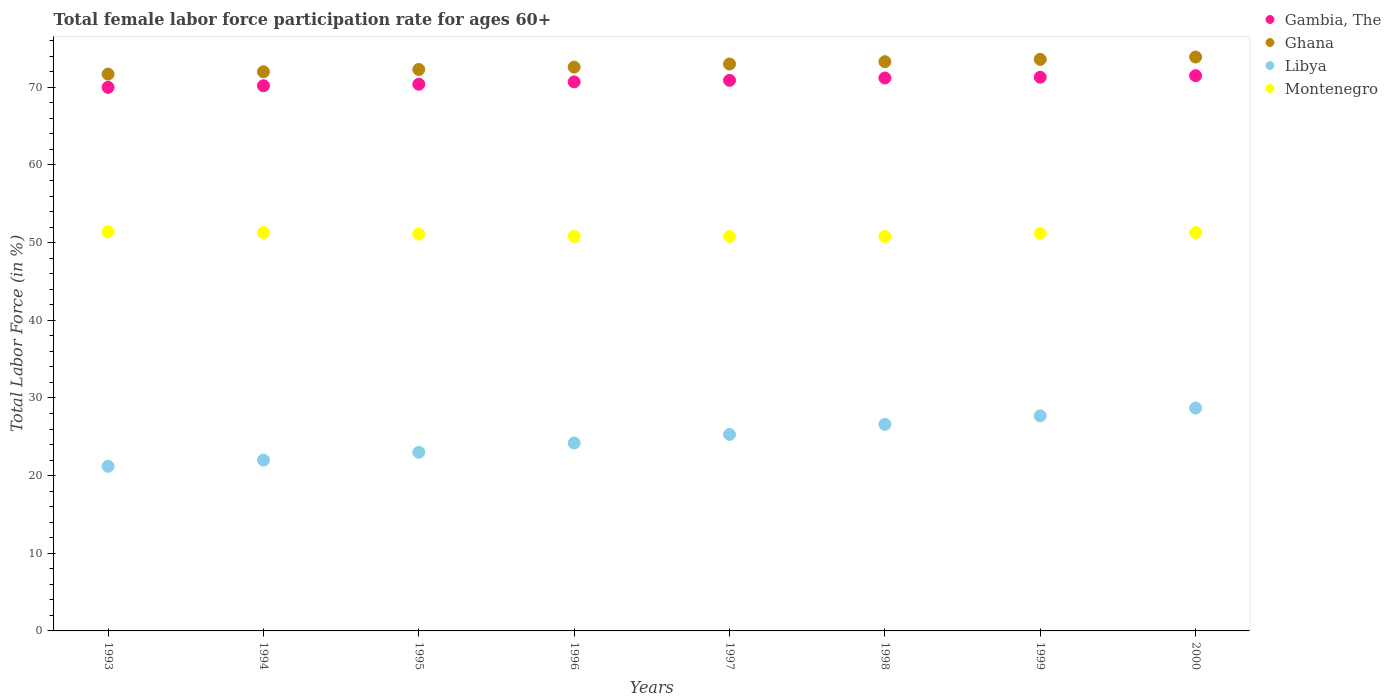What is the female labor force participation rate in Gambia, The in 1997?
Give a very brief answer. 70.9. Across all years, what is the maximum female labor force participation rate in Gambia, The?
Your answer should be compact. 71.5. Across all years, what is the minimum female labor force participation rate in Ghana?
Ensure brevity in your answer.  71.7. In which year was the female labor force participation rate in Libya maximum?
Provide a short and direct response. 2000. What is the total female labor force participation rate in Ghana in the graph?
Your response must be concise. 582.4. What is the difference between the female labor force participation rate in Ghana in 1995 and that in 1999?
Offer a terse response. -1.3. What is the difference between the female labor force participation rate in Ghana in 1994 and the female labor force participation rate in Montenegro in 1996?
Your response must be concise. 21.2. What is the average female labor force participation rate in Gambia, The per year?
Offer a terse response. 70.77. In the year 1993, what is the difference between the female labor force participation rate in Ghana and female labor force participation rate in Montenegro?
Give a very brief answer. 20.3. What is the ratio of the female labor force participation rate in Montenegro in 1995 to that in 2000?
Your answer should be compact. 1. Is the female labor force participation rate in Libya in 1995 less than that in 2000?
Offer a very short reply. Yes. Is the difference between the female labor force participation rate in Ghana in 1998 and 2000 greater than the difference between the female labor force participation rate in Montenegro in 1998 and 2000?
Offer a terse response. No. What is the difference between the highest and the second highest female labor force participation rate in Ghana?
Provide a short and direct response. 0.3. What is the difference between the highest and the lowest female labor force participation rate in Ghana?
Your answer should be very brief. 2.2. Is the sum of the female labor force participation rate in Montenegro in 1998 and 1999 greater than the maximum female labor force participation rate in Libya across all years?
Your answer should be compact. Yes. Is it the case that in every year, the sum of the female labor force participation rate in Libya and female labor force participation rate in Ghana  is greater than the female labor force participation rate in Gambia, The?
Provide a short and direct response. Yes. How many years are there in the graph?
Your answer should be compact. 8. Are the values on the major ticks of Y-axis written in scientific E-notation?
Your answer should be very brief. No. Where does the legend appear in the graph?
Your answer should be very brief. Top right. How many legend labels are there?
Provide a short and direct response. 4. How are the legend labels stacked?
Your response must be concise. Vertical. What is the title of the graph?
Provide a succinct answer. Total female labor force participation rate for ages 60+. Does "Iceland" appear as one of the legend labels in the graph?
Offer a very short reply. No. What is the label or title of the X-axis?
Ensure brevity in your answer.  Years. What is the label or title of the Y-axis?
Provide a succinct answer. Total Labor Force (in %). What is the Total Labor Force (in %) of Gambia, The in 1993?
Your response must be concise. 70. What is the Total Labor Force (in %) of Ghana in 1993?
Ensure brevity in your answer.  71.7. What is the Total Labor Force (in %) of Libya in 1993?
Keep it short and to the point. 21.2. What is the Total Labor Force (in %) in Montenegro in 1993?
Give a very brief answer. 51.4. What is the Total Labor Force (in %) in Gambia, The in 1994?
Your answer should be compact. 70.2. What is the Total Labor Force (in %) of Ghana in 1994?
Give a very brief answer. 72. What is the Total Labor Force (in %) in Montenegro in 1994?
Your answer should be compact. 51.3. What is the Total Labor Force (in %) of Gambia, The in 1995?
Keep it short and to the point. 70.4. What is the Total Labor Force (in %) in Ghana in 1995?
Your response must be concise. 72.3. What is the Total Labor Force (in %) of Libya in 1995?
Make the answer very short. 23. What is the Total Labor Force (in %) in Montenegro in 1995?
Your response must be concise. 51.1. What is the Total Labor Force (in %) in Gambia, The in 1996?
Offer a very short reply. 70.7. What is the Total Labor Force (in %) of Ghana in 1996?
Offer a very short reply. 72.6. What is the Total Labor Force (in %) of Libya in 1996?
Provide a short and direct response. 24.2. What is the Total Labor Force (in %) of Montenegro in 1996?
Offer a terse response. 50.8. What is the Total Labor Force (in %) of Gambia, The in 1997?
Offer a very short reply. 70.9. What is the Total Labor Force (in %) of Libya in 1997?
Offer a terse response. 25.3. What is the Total Labor Force (in %) of Montenegro in 1997?
Offer a very short reply. 50.8. What is the Total Labor Force (in %) of Gambia, The in 1998?
Your answer should be compact. 71.2. What is the Total Labor Force (in %) in Ghana in 1998?
Provide a succinct answer. 73.3. What is the Total Labor Force (in %) in Libya in 1998?
Give a very brief answer. 26.6. What is the Total Labor Force (in %) in Montenegro in 1998?
Offer a terse response. 50.8. What is the Total Labor Force (in %) of Gambia, The in 1999?
Provide a succinct answer. 71.3. What is the Total Labor Force (in %) of Ghana in 1999?
Make the answer very short. 73.6. What is the Total Labor Force (in %) of Libya in 1999?
Your answer should be very brief. 27.7. What is the Total Labor Force (in %) in Montenegro in 1999?
Give a very brief answer. 51.2. What is the Total Labor Force (in %) in Gambia, The in 2000?
Your answer should be very brief. 71.5. What is the Total Labor Force (in %) of Ghana in 2000?
Your response must be concise. 73.9. What is the Total Labor Force (in %) of Libya in 2000?
Make the answer very short. 28.7. What is the Total Labor Force (in %) of Montenegro in 2000?
Your answer should be compact. 51.3. Across all years, what is the maximum Total Labor Force (in %) in Gambia, The?
Keep it short and to the point. 71.5. Across all years, what is the maximum Total Labor Force (in %) in Ghana?
Offer a terse response. 73.9. Across all years, what is the maximum Total Labor Force (in %) in Libya?
Your answer should be compact. 28.7. Across all years, what is the maximum Total Labor Force (in %) in Montenegro?
Ensure brevity in your answer.  51.4. Across all years, what is the minimum Total Labor Force (in %) in Gambia, The?
Provide a succinct answer. 70. Across all years, what is the minimum Total Labor Force (in %) in Ghana?
Provide a short and direct response. 71.7. Across all years, what is the minimum Total Labor Force (in %) of Libya?
Offer a very short reply. 21.2. Across all years, what is the minimum Total Labor Force (in %) in Montenegro?
Provide a succinct answer. 50.8. What is the total Total Labor Force (in %) in Gambia, The in the graph?
Your answer should be compact. 566.2. What is the total Total Labor Force (in %) in Ghana in the graph?
Ensure brevity in your answer.  582.4. What is the total Total Labor Force (in %) in Libya in the graph?
Your answer should be compact. 198.7. What is the total Total Labor Force (in %) of Montenegro in the graph?
Make the answer very short. 408.7. What is the difference between the Total Labor Force (in %) of Gambia, The in 1993 and that in 1994?
Give a very brief answer. -0.2. What is the difference between the Total Labor Force (in %) of Ghana in 1993 and that in 1994?
Your answer should be very brief. -0.3. What is the difference between the Total Labor Force (in %) in Gambia, The in 1993 and that in 1997?
Your response must be concise. -0.9. What is the difference between the Total Labor Force (in %) in Ghana in 1993 and that in 1997?
Your answer should be very brief. -1.3. What is the difference between the Total Labor Force (in %) in Libya in 1993 and that in 1997?
Offer a very short reply. -4.1. What is the difference between the Total Labor Force (in %) of Gambia, The in 1993 and that in 1998?
Make the answer very short. -1.2. What is the difference between the Total Labor Force (in %) of Ghana in 1993 and that in 1998?
Your answer should be very brief. -1.6. What is the difference between the Total Labor Force (in %) in Montenegro in 1993 and that in 1998?
Keep it short and to the point. 0.6. What is the difference between the Total Labor Force (in %) of Gambia, The in 1993 and that in 1999?
Your answer should be very brief. -1.3. What is the difference between the Total Labor Force (in %) in Ghana in 1993 and that in 2000?
Your answer should be compact. -2.2. What is the difference between the Total Labor Force (in %) of Libya in 1994 and that in 1995?
Offer a terse response. -1. What is the difference between the Total Labor Force (in %) of Gambia, The in 1994 and that in 1996?
Keep it short and to the point. -0.5. What is the difference between the Total Labor Force (in %) of Ghana in 1994 and that in 1997?
Provide a short and direct response. -1. What is the difference between the Total Labor Force (in %) of Gambia, The in 1994 and that in 1998?
Provide a short and direct response. -1. What is the difference between the Total Labor Force (in %) in Ghana in 1994 and that in 1998?
Your response must be concise. -1.3. What is the difference between the Total Labor Force (in %) of Montenegro in 1994 and that in 1998?
Keep it short and to the point. 0.5. What is the difference between the Total Labor Force (in %) of Gambia, The in 1994 and that in 1999?
Give a very brief answer. -1.1. What is the difference between the Total Labor Force (in %) in Ghana in 1994 and that in 1999?
Your response must be concise. -1.6. What is the difference between the Total Labor Force (in %) in Libya in 1994 and that in 1999?
Offer a terse response. -5.7. What is the difference between the Total Labor Force (in %) in Montenegro in 1994 and that in 1999?
Ensure brevity in your answer.  0.1. What is the difference between the Total Labor Force (in %) in Ghana in 1994 and that in 2000?
Offer a terse response. -1.9. What is the difference between the Total Labor Force (in %) in Libya in 1994 and that in 2000?
Keep it short and to the point. -6.7. What is the difference between the Total Labor Force (in %) in Montenegro in 1994 and that in 2000?
Your response must be concise. 0. What is the difference between the Total Labor Force (in %) of Libya in 1995 and that in 1996?
Offer a very short reply. -1.2. What is the difference between the Total Labor Force (in %) in Ghana in 1995 and that in 1997?
Provide a succinct answer. -0.7. What is the difference between the Total Labor Force (in %) of Libya in 1995 and that in 1997?
Provide a short and direct response. -2.3. What is the difference between the Total Labor Force (in %) in Montenegro in 1995 and that in 1997?
Your answer should be very brief. 0.3. What is the difference between the Total Labor Force (in %) in Gambia, The in 1995 and that in 1998?
Ensure brevity in your answer.  -0.8. What is the difference between the Total Labor Force (in %) of Ghana in 1995 and that in 1998?
Offer a very short reply. -1. What is the difference between the Total Labor Force (in %) of Libya in 1995 and that in 1998?
Offer a very short reply. -3.6. What is the difference between the Total Labor Force (in %) in Montenegro in 1995 and that in 1998?
Make the answer very short. 0.3. What is the difference between the Total Labor Force (in %) in Gambia, The in 1995 and that in 1999?
Your response must be concise. -0.9. What is the difference between the Total Labor Force (in %) of Ghana in 1995 and that in 1999?
Offer a very short reply. -1.3. What is the difference between the Total Labor Force (in %) of Montenegro in 1995 and that in 1999?
Offer a very short reply. -0.1. What is the difference between the Total Labor Force (in %) in Gambia, The in 1995 and that in 2000?
Provide a succinct answer. -1.1. What is the difference between the Total Labor Force (in %) of Ghana in 1995 and that in 2000?
Give a very brief answer. -1.6. What is the difference between the Total Labor Force (in %) in Libya in 1995 and that in 2000?
Offer a very short reply. -5.7. What is the difference between the Total Labor Force (in %) in Gambia, The in 1996 and that in 1997?
Provide a short and direct response. -0.2. What is the difference between the Total Labor Force (in %) of Ghana in 1996 and that in 1997?
Provide a short and direct response. -0.4. What is the difference between the Total Labor Force (in %) in Libya in 1996 and that in 1997?
Give a very brief answer. -1.1. What is the difference between the Total Labor Force (in %) of Montenegro in 1996 and that in 1997?
Offer a very short reply. 0. What is the difference between the Total Labor Force (in %) in Ghana in 1996 and that in 1998?
Make the answer very short. -0.7. What is the difference between the Total Labor Force (in %) of Montenegro in 1996 and that in 1998?
Keep it short and to the point. 0. What is the difference between the Total Labor Force (in %) in Libya in 1996 and that in 1999?
Offer a very short reply. -3.5. What is the difference between the Total Labor Force (in %) of Libya in 1997 and that in 1998?
Ensure brevity in your answer.  -1.3. What is the difference between the Total Labor Force (in %) in Gambia, The in 1997 and that in 1999?
Provide a short and direct response. -0.4. What is the difference between the Total Labor Force (in %) of Ghana in 1997 and that in 1999?
Your answer should be very brief. -0.6. What is the difference between the Total Labor Force (in %) in Libya in 1997 and that in 1999?
Your response must be concise. -2.4. What is the difference between the Total Labor Force (in %) in Montenegro in 1997 and that in 1999?
Your response must be concise. -0.4. What is the difference between the Total Labor Force (in %) in Gambia, The in 1997 and that in 2000?
Offer a very short reply. -0.6. What is the difference between the Total Labor Force (in %) of Ghana in 1997 and that in 2000?
Your response must be concise. -0.9. What is the difference between the Total Labor Force (in %) of Libya in 1997 and that in 2000?
Offer a terse response. -3.4. What is the difference between the Total Labor Force (in %) in Gambia, The in 1998 and that in 1999?
Provide a succinct answer. -0.1. What is the difference between the Total Labor Force (in %) in Ghana in 1998 and that in 1999?
Provide a succinct answer. -0.3. What is the difference between the Total Labor Force (in %) in Libya in 1998 and that in 1999?
Your answer should be compact. -1.1. What is the difference between the Total Labor Force (in %) in Ghana in 1998 and that in 2000?
Your answer should be very brief. -0.6. What is the difference between the Total Labor Force (in %) of Libya in 1998 and that in 2000?
Make the answer very short. -2.1. What is the difference between the Total Labor Force (in %) in Gambia, The in 1999 and that in 2000?
Provide a succinct answer. -0.2. What is the difference between the Total Labor Force (in %) of Libya in 1999 and that in 2000?
Your answer should be very brief. -1. What is the difference between the Total Labor Force (in %) in Montenegro in 1999 and that in 2000?
Give a very brief answer. -0.1. What is the difference between the Total Labor Force (in %) of Gambia, The in 1993 and the Total Labor Force (in %) of Ghana in 1994?
Your answer should be very brief. -2. What is the difference between the Total Labor Force (in %) in Ghana in 1993 and the Total Labor Force (in %) in Libya in 1994?
Provide a succinct answer. 49.7. What is the difference between the Total Labor Force (in %) in Ghana in 1993 and the Total Labor Force (in %) in Montenegro in 1994?
Your answer should be compact. 20.4. What is the difference between the Total Labor Force (in %) in Libya in 1993 and the Total Labor Force (in %) in Montenegro in 1994?
Your response must be concise. -30.1. What is the difference between the Total Labor Force (in %) in Gambia, The in 1993 and the Total Labor Force (in %) in Ghana in 1995?
Your answer should be compact. -2.3. What is the difference between the Total Labor Force (in %) in Gambia, The in 1993 and the Total Labor Force (in %) in Libya in 1995?
Your answer should be very brief. 47. What is the difference between the Total Labor Force (in %) of Ghana in 1993 and the Total Labor Force (in %) of Libya in 1995?
Ensure brevity in your answer.  48.7. What is the difference between the Total Labor Force (in %) in Ghana in 1993 and the Total Labor Force (in %) in Montenegro in 1995?
Give a very brief answer. 20.6. What is the difference between the Total Labor Force (in %) in Libya in 1993 and the Total Labor Force (in %) in Montenegro in 1995?
Provide a short and direct response. -29.9. What is the difference between the Total Labor Force (in %) of Gambia, The in 1993 and the Total Labor Force (in %) of Ghana in 1996?
Your answer should be compact. -2.6. What is the difference between the Total Labor Force (in %) in Gambia, The in 1993 and the Total Labor Force (in %) in Libya in 1996?
Your response must be concise. 45.8. What is the difference between the Total Labor Force (in %) of Gambia, The in 1993 and the Total Labor Force (in %) of Montenegro in 1996?
Keep it short and to the point. 19.2. What is the difference between the Total Labor Force (in %) in Ghana in 1993 and the Total Labor Force (in %) in Libya in 1996?
Provide a succinct answer. 47.5. What is the difference between the Total Labor Force (in %) in Ghana in 1993 and the Total Labor Force (in %) in Montenegro in 1996?
Provide a succinct answer. 20.9. What is the difference between the Total Labor Force (in %) in Libya in 1993 and the Total Labor Force (in %) in Montenegro in 1996?
Ensure brevity in your answer.  -29.6. What is the difference between the Total Labor Force (in %) in Gambia, The in 1993 and the Total Labor Force (in %) in Ghana in 1997?
Provide a short and direct response. -3. What is the difference between the Total Labor Force (in %) of Gambia, The in 1993 and the Total Labor Force (in %) of Libya in 1997?
Offer a very short reply. 44.7. What is the difference between the Total Labor Force (in %) in Gambia, The in 1993 and the Total Labor Force (in %) in Montenegro in 1997?
Keep it short and to the point. 19.2. What is the difference between the Total Labor Force (in %) in Ghana in 1993 and the Total Labor Force (in %) in Libya in 1997?
Make the answer very short. 46.4. What is the difference between the Total Labor Force (in %) of Ghana in 1993 and the Total Labor Force (in %) of Montenegro in 1997?
Offer a very short reply. 20.9. What is the difference between the Total Labor Force (in %) in Libya in 1993 and the Total Labor Force (in %) in Montenegro in 1997?
Make the answer very short. -29.6. What is the difference between the Total Labor Force (in %) of Gambia, The in 1993 and the Total Labor Force (in %) of Ghana in 1998?
Give a very brief answer. -3.3. What is the difference between the Total Labor Force (in %) of Gambia, The in 1993 and the Total Labor Force (in %) of Libya in 1998?
Ensure brevity in your answer.  43.4. What is the difference between the Total Labor Force (in %) in Ghana in 1993 and the Total Labor Force (in %) in Libya in 1998?
Keep it short and to the point. 45.1. What is the difference between the Total Labor Force (in %) of Ghana in 1993 and the Total Labor Force (in %) of Montenegro in 1998?
Your response must be concise. 20.9. What is the difference between the Total Labor Force (in %) in Libya in 1993 and the Total Labor Force (in %) in Montenegro in 1998?
Provide a short and direct response. -29.6. What is the difference between the Total Labor Force (in %) of Gambia, The in 1993 and the Total Labor Force (in %) of Ghana in 1999?
Your answer should be compact. -3.6. What is the difference between the Total Labor Force (in %) of Gambia, The in 1993 and the Total Labor Force (in %) of Libya in 1999?
Offer a very short reply. 42.3. What is the difference between the Total Labor Force (in %) in Ghana in 1993 and the Total Labor Force (in %) in Libya in 1999?
Ensure brevity in your answer.  44. What is the difference between the Total Labor Force (in %) in Ghana in 1993 and the Total Labor Force (in %) in Montenegro in 1999?
Keep it short and to the point. 20.5. What is the difference between the Total Labor Force (in %) of Gambia, The in 1993 and the Total Labor Force (in %) of Ghana in 2000?
Make the answer very short. -3.9. What is the difference between the Total Labor Force (in %) of Gambia, The in 1993 and the Total Labor Force (in %) of Libya in 2000?
Your answer should be compact. 41.3. What is the difference between the Total Labor Force (in %) of Gambia, The in 1993 and the Total Labor Force (in %) of Montenegro in 2000?
Make the answer very short. 18.7. What is the difference between the Total Labor Force (in %) in Ghana in 1993 and the Total Labor Force (in %) in Libya in 2000?
Keep it short and to the point. 43. What is the difference between the Total Labor Force (in %) of Ghana in 1993 and the Total Labor Force (in %) of Montenegro in 2000?
Provide a succinct answer. 20.4. What is the difference between the Total Labor Force (in %) in Libya in 1993 and the Total Labor Force (in %) in Montenegro in 2000?
Ensure brevity in your answer.  -30.1. What is the difference between the Total Labor Force (in %) of Gambia, The in 1994 and the Total Labor Force (in %) of Ghana in 1995?
Give a very brief answer. -2.1. What is the difference between the Total Labor Force (in %) in Gambia, The in 1994 and the Total Labor Force (in %) in Libya in 1995?
Your answer should be compact. 47.2. What is the difference between the Total Labor Force (in %) of Gambia, The in 1994 and the Total Labor Force (in %) of Montenegro in 1995?
Make the answer very short. 19.1. What is the difference between the Total Labor Force (in %) in Ghana in 1994 and the Total Labor Force (in %) in Libya in 1995?
Your answer should be very brief. 49. What is the difference between the Total Labor Force (in %) in Ghana in 1994 and the Total Labor Force (in %) in Montenegro in 1995?
Give a very brief answer. 20.9. What is the difference between the Total Labor Force (in %) of Libya in 1994 and the Total Labor Force (in %) of Montenegro in 1995?
Ensure brevity in your answer.  -29.1. What is the difference between the Total Labor Force (in %) of Gambia, The in 1994 and the Total Labor Force (in %) of Libya in 1996?
Provide a succinct answer. 46. What is the difference between the Total Labor Force (in %) of Gambia, The in 1994 and the Total Labor Force (in %) of Montenegro in 1996?
Your response must be concise. 19.4. What is the difference between the Total Labor Force (in %) in Ghana in 1994 and the Total Labor Force (in %) in Libya in 1996?
Offer a very short reply. 47.8. What is the difference between the Total Labor Force (in %) of Ghana in 1994 and the Total Labor Force (in %) of Montenegro in 1996?
Provide a short and direct response. 21.2. What is the difference between the Total Labor Force (in %) of Libya in 1994 and the Total Labor Force (in %) of Montenegro in 1996?
Ensure brevity in your answer.  -28.8. What is the difference between the Total Labor Force (in %) of Gambia, The in 1994 and the Total Labor Force (in %) of Ghana in 1997?
Give a very brief answer. -2.8. What is the difference between the Total Labor Force (in %) of Gambia, The in 1994 and the Total Labor Force (in %) of Libya in 1997?
Provide a succinct answer. 44.9. What is the difference between the Total Labor Force (in %) of Gambia, The in 1994 and the Total Labor Force (in %) of Montenegro in 1997?
Keep it short and to the point. 19.4. What is the difference between the Total Labor Force (in %) of Ghana in 1994 and the Total Labor Force (in %) of Libya in 1997?
Your answer should be very brief. 46.7. What is the difference between the Total Labor Force (in %) of Ghana in 1994 and the Total Labor Force (in %) of Montenegro in 1997?
Make the answer very short. 21.2. What is the difference between the Total Labor Force (in %) of Libya in 1994 and the Total Labor Force (in %) of Montenegro in 1997?
Your answer should be compact. -28.8. What is the difference between the Total Labor Force (in %) of Gambia, The in 1994 and the Total Labor Force (in %) of Libya in 1998?
Ensure brevity in your answer.  43.6. What is the difference between the Total Labor Force (in %) of Ghana in 1994 and the Total Labor Force (in %) of Libya in 1998?
Your response must be concise. 45.4. What is the difference between the Total Labor Force (in %) in Ghana in 1994 and the Total Labor Force (in %) in Montenegro in 1998?
Offer a terse response. 21.2. What is the difference between the Total Labor Force (in %) in Libya in 1994 and the Total Labor Force (in %) in Montenegro in 1998?
Your response must be concise. -28.8. What is the difference between the Total Labor Force (in %) of Gambia, The in 1994 and the Total Labor Force (in %) of Libya in 1999?
Offer a very short reply. 42.5. What is the difference between the Total Labor Force (in %) of Gambia, The in 1994 and the Total Labor Force (in %) of Montenegro in 1999?
Provide a short and direct response. 19. What is the difference between the Total Labor Force (in %) of Ghana in 1994 and the Total Labor Force (in %) of Libya in 1999?
Your answer should be compact. 44.3. What is the difference between the Total Labor Force (in %) of Ghana in 1994 and the Total Labor Force (in %) of Montenegro in 1999?
Provide a short and direct response. 20.8. What is the difference between the Total Labor Force (in %) in Libya in 1994 and the Total Labor Force (in %) in Montenegro in 1999?
Make the answer very short. -29.2. What is the difference between the Total Labor Force (in %) of Gambia, The in 1994 and the Total Labor Force (in %) of Ghana in 2000?
Keep it short and to the point. -3.7. What is the difference between the Total Labor Force (in %) in Gambia, The in 1994 and the Total Labor Force (in %) in Libya in 2000?
Offer a very short reply. 41.5. What is the difference between the Total Labor Force (in %) in Ghana in 1994 and the Total Labor Force (in %) in Libya in 2000?
Your answer should be very brief. 43.3. What is the difference between the Total Labor Force (in %) of Ghana in 1994 and the Total Labor Force (in %) of Montenegro in 2000?
Keep it short and to the point. 20.7. What is the difference between the Total Labor Force (in %) of Libya in 1994 and the Total Labor Force (in %) of Montenegro in 2000?
Offer a very short reply. -29.3. What is the difference between the Total Labor Force (in %) in Gambia, The in 1995 and the Total Labor Force (in %) in Libya in 1996?
Provide a short and direct response. 46.2. What is the difference between the Total Labor Force (in %) in Gambia, The in 1995 and the Total Labor Force (in %) in Montenegro in 1996?
Offer a very short reply. 19.6. What is the difference between the Total Labor Force (in %) of Ghana in 1995 and the Total Labor Force (in %) of Libya in 1996?
Give a very brief answer. 48.1. What is the difference between the Total Labor Force (in %) of Ghana in 1995 and the Total Labor Force (in %) of Montenegro in 1996?
Keep it short and to the point. 21.5. What is the difference between the Total Labor Force (in %) of Libya in 1995 and the Total Labor Force (in %) of Montenegro in 1996?
Your answer should be very brief. -27.8. What is the difference between the Total Labor Force (in %) of Gambia, The in 1995 and the Total Labor Force (in %) of Libya in 1997?
Provide a short and direct response. 45.1. What is the difference between the Total Labor Force (in %) of Gambia, The in 1995 and the Total Labor Force (in %) of Montenegro in 1997?
Offer a very short reply. 19.6. What is the difference between the Total Labor Force (in %) of Ghana in 1995 and the Total Labor Force (in %) of Montenegro in 1997?
Give a very brief answer. 21.5. What is the difference between the Total Labor Force (in %) in Libya in 1995 and the Total Labor Force (in %) in Montenegro in 1997?
Your answer should be compact. -27.8. What is the difference between the Total Labor Force (in %) in Gambia, The in 1995 and the Total Labor Force (in %) in Libya in 1998?
Keep it short and to the point. 43.8. What is the difference between the Total Labor Force (in %) of Gambia, The in 1995 and the Total Labor Force (in %) of Montenegro in 1998?
Your response must be concise. 19.6. What is the difference between the Total Labor Force (in %) in Ghana in 1995 and the Total Labor Force (in %) in Libya in 1998?
Give a very brief answer. 45.7. What is the difference between the Total Labor Force (in %) of Libya in 1995 and the Total Labor Force (in %) of Montenegro in 1998?
Offer a very short reply. -27.8. What is the difference between the Total Labor Force (in %) of Gambia, The in 1995 and the Total Labor Force (in %) of Libya in 1999?
Keep it short and to the point. 42.7. What is the difference between the Total Labor Force (in %) of Ghana in 1995 and the Total Labor Force (in %) of Libya in 1999?
Make the answer very short. 44.6. What is the difference between the Total Labor Force (in %) of Ghana in 1995 and the Total Labor Force (in %) of Montenegro in 1999?
Your answer should be very brief. 21.1. What is the difference between the Total Labor Force (in %) of Libya in 1995 and the Total Labor Force (in %) of Montenegro in 1999?
Give a very brief answer. -28.2. What is the difference between the Total Labor Force (in %) in Gambia, The in 1995 and the Total Labor Force (in %) in Libya in 2000?
Give a very brief answer. 41.7. What is the difference between the Total Labor Force (in %) in Ghana in 1995 and the Total Labor Force (in %) in Libya in 2000?
Offer a very short reply. 43.6. What is the difference between the Total Labor Force (in %) of Libya in 1995 and the Total Labor Force (in %) of Montenegro in 2000?
Give a very brief answer. -28.3. What is the difference between the Total Labor Force (in %) in Gambia, The in 1996 and the Total Labor Force (in %) in Libya in 1997?
Ensure brevity in your answer.  45.4. What is the difference between the Total Labor Force (in %) of Gambia, The in 1996 and the Total Labor Force (in %) of Montenegro in 1997?
Provide a short and direct response. 19.9. What is the difference between the Total Labor Force (in %) in Ghana in 1996 and the Total Labor Force (in %) in Libya in 1997?
Offer a very short reply. 47.3. What is the difference between the Total Labor Force (in %) of Ghana in 1996 and the Total Labor Force (in %) of Montenegro in 1997?
Your answer should be very brief. 21.8. What is the difference between the Total Labor Force (in %) of Libya in 1996 and the Total Labor Force (in %) of Montenegro in 1997?
Provide a succinct answer. -26.6. What is the difference between the Total Labor Force (in %) in Gambia, The in 1996 and the Total Labor Force (in %) in Ghana in 1998?
Provide a succinct answer. -2.6. What is the difference between the Total Labor Force (in %) in Gambia, The in 1996 and the Total Labor Force (in %) in Libya in 1998?
Make the answer very short. 44.1. What is the difference between the Total Labor Force (in %) of Gambia, The in 1996 and the Total Labor Force (in %) of Montenegro in 1998?
Provide a succinct answer. 19.9. What is the difference between the Total Labor Force (in %) in Ghana in 1996 and the Total Labor Force (in %) in Montenegro in 1998?
Your response must be concise. 21.8. What is the difference between the Total Labor Force (in %) of Libya in 1996 and the Total Labor Force (in %) of Montenegro in 1998?
Provide a succinct answer. -26.6. What is the difference between the Total Labor Force (in %) of Gambia, The in 1996 and the Total Labor Force (in %) of Ghana in 1999?
Your answer should be compact. -2.9. What is the difference between the Total Labor Force (in %) in Ghana in 1996 and the Total Labor Force (in %) in Libya in 1999?
Keep it short and to the point. 44.9. What is the difference between the Total Labor Force (in %) in Ghana in 1996 and the Total Labor Force (in %) in Montenegro in 1999?
Offer a very short reply. 21.4. What is the difference between the Total Labor Force (in %) in Gambia, The in 1996 and the Total Labor Force (in %) in Libya in 2000?
Offer a very short reply. 42. What is the difference between the Total Labor Force (in %) of Ghana in 1996 and the Total Labor Force (in %) of Libya in 2000?
Your response must be concise. 43.9. What is the difference between the Total Labor Force (in %) of Ghana in 1996 and the Total Labor Force (in %) of Montenegro in 2000?
Your answer should be very brief. 21.3. What is the difference between the Total Labor Force (in %) in Libya in 1996 and the Total Labor Force (in %) in Montenegro in 2000?
Give a very brief answer. -27.1. What is the difference between the Total Labor Force (in %) of Gambia, The in 1997 and the Total Labor Force (in %) of Libya in 1998?
Make the answer very short. 44.3. What is the difference between the Total Labor Force (in %) of Gambia, The in 1997 and the Total Labor Force (in %) of Montenegro in 1998?
Offer a terse response. 20.1. What is the difference between the Total Labor Force (in %) in Ghana in 1997 and the Total Labor Force (in %) in Libya in 1998?
Ensure brevity in your answer.  46.4. What is the difference between the Total Labor Force (in %) of Libya in 1997 and the Total Labor Force (in %) of Montenegro in 1998?
Your answer should be very brief. -25.5. What is the difference between the Total Labor Force (in %) of Gambia, The in 1997 and the Total Labor Force (in %) of Ghana in 1999?
Make the answer very short. -2.7. What is the difference between the Total Labor Force (in %) of Gambia, The in 1997 and the Total Labor Force (in %) of Libya in 1999?
Ensure brevity in your answer.  43.2. What is the difference between the Total Labor Force (in %) of Ghana in 1997 and the Total Labor Force (in %) of Libya in 1999?
Provide a short and direct response. 45.3. What is the difference between the Total Labor Force (in %) in Ghana in 1997 and the Total Labor Force (in %) in Montenegro in 1999?
Make the answer very short. 21.8. What is the difference between the Total Labor Force (in %) of Libya in 1997 and the Total Labor Force (in %) of Montenegro in 1999?
Your answer should be very brief. -25.9. What is the difference between the Total Labor Force (in %) in Gambia, The in 1997 and the Total Labor Force (in %) in Libya in 2000?
Provide a short and direct response. 42.2. What is the difference between the Total Labor Force (in %) of Gambia, The in 1997 and the Total Labor Force (in %) of Montenegro in 2000?
Your answer should be very brief. 19.6. What is the difference between the Total Labor Force (in %) of Ghana in 1997 and the Total Labor Force (in %) of Libya in 2000?
Your response must be concise. 44.3. What is the difference between the Total Labor Force (in %) in Ghana in 1997 and the Total Labor Force (in %) in Montenegro in 2000?
Ensure brevity in your answer.  21.7. What is the difference between the Total Labor Force (in %) of Gambia, The in 1998 and the Total Labor Force (in %) of Ghana in 1999?
Offer a very short reply. -2.4. What is the difference between the Total Labor Force (in %) of Gambia, The in 1998 and the Total Labor Force (in %) of Libya in 1999?
Ensure brevity in your answer.  43.5. What is the difference between the Total Labor Force (in %) in Gambia, The in 1998 and the Total Labor Force (in %) in Montenegro in 1999?
Ensure brevity in your answer.  20. What is the difference between the Total Labor Force (in %) of Ghana in 1998 and the Total Labor Force (in %) of Libya in 1999?
Your answer should be very brief. 45.6. What is the difference between the Total Labor Force (in %) of Ghana in 1998 and the Total Labor Force (in %) of Montenegro in 1999?
Provide a succinct answer. 22.1. What is the difference between the Total Labor Force (in %) of Libya in 1998 and the Total Labor Force (in %) of Montenegro in 1999?
Provide a succinct answer. -24.6. What is the difference between the Total Labor Force (in %) of Gambia, The in 1998 and the Total Labor Force (in %) of Ghana in 2000?
Offer a very short reply. -2.7. What is the difference between the Total Labor Force (in %) of Gambia, The in 1998 and the Total Labor Force (in %) of Libya in 2000?
Keep it short and to the point. 42.5. What is the difference between the Total Labor Force (in %) of Ghana in 1998 and the Total Labor Force (in %) of Libya in 2000?
Give a very brief answer. 44.6. What is the difference between the Total Labor Force (in %) in Ghana in 1998 and the Total Labor Force (in %) in Montenegro in 2000?
Your answer should be compact. 22. What is the difference between the Total Labor Force (in %) in Libya in 1998 and the Total Labor Force (in %) in Montenegro in 2000?
Make the answer very short. -24.7. What is the difference between the Total Labor Force (in %) of Gambia, The in 1999 and the Total Labor Force (in %) of Ghana in 2000?
Your answer should be very brief. -2.6. What is the difference between the Total Labor Force (in %) in Gambia, The in 1999 and the Total Labor Force (in %) in Libya in 2000?
Make the answer very short. 42.6. What is the difference between the Total Labor Force (in %) of Ghana in 1999 and the Total Labor Force (in %) of Libya in 2000?
Offer a very short reply. 44.9. What is the difference between the Total Labor Force (in %) of Ghana in 1999 and the Total Labor Force (in %) of Montenegro in 2000?
Give a very brief answer. 22.3. What is the difference between the Total Labor Force (in %) in Libya in 1999 and the Total Labor Force (in %) in Montenegro in 2000?
Offer a very short reply. -23.6. What is the average Total Labor Force (in %) of Gambia, The per year?
Offer a terse response. 70.78. What is the average Total Labor Force (in %) in Ghana per year?
Offer a terse response. 72.8. What is the average Total Labor Force (in %) of Libya per year?
Your response must be concise. 24.84. What is the average Total Labor Force (in %) in Montenegro per year?
Your answer should be compact. 51.09. In the year 1993, what is the difference between the Total Labor Force (in %) in Gambia, The and Total Labor Force (in %) in Libya?
Your response must be concise. 48.8. In the year 1993, what is the difference between the Total Labor Force (in %) of Ghana and Total Labor Force (in %) of Libya?
Give a very brief answer. 50.5. In the year 1993, what is the difference between the Total Labor Force (in %) of Ghana and Total Labor Force (in %) of Montenegro?
Keep it short and to the point. 20.3. In the year 1993, what is the difference between the Total Labor Force (in %) in Libya and Total Labor Force (in %) in Montenegro?
Your response must be concise. -30.2. In the year 1994, what is the difference between the Total Labor Force (in %) of Gambia, The and Total Labor Force (in %) of Ghana?
Make the answer very short. -1.8. In the year 1994, what is the difference between the Total Labor Force (in %) in Gambia, The and Total Labor Force (in %) in Libya?
Your response must be concise. 48.2. In the year 1994, what is the difference between the Total Labor Force (in %) in Ghana and Total Labor Force (in %) in Libya?
Ensure brevity in your answer.  50. In the year 1994, what is the difference between the Total Labor Force (in %) of Ghana and Total Labor Force (in %) of Montenegro?
Make the answer very short. 20.7. In the year 1994, what is the difference between the Total Labor Force (in %) of Libya and Total Labor Force (in %) of Montenegro?
Offer a very short reply. -29.3. In the year 1995, what is the difference between the Total Labor Force (in %) in Gambia, The and Total Labor Force (in %) in Ghana?
Keep it short and to the point. -1.9. In the year 1995, what is the difference between the Total Labor Force (in %) of Gambia, The and Total Labor Force (in %) of Libya?
Offer a very short reply. 47.4. In the year 1995, what is the difference between the Total Labor Force (in %) of Gambia, The and Total Labor Force (in %) of Montenegro?
Make the answer very short. 19.3. In the year 1995, what is the difference between the Total Labor Force (in %) of Ghana and Total Labor Force (in %) of Libya?
Ensure brevity in your answer.  49.3. In the year 1995, what is the difference between the Total Labor Force (in %) of Ghana and Total Labor Force (in %) of Montenegro?
Ensure brevity in your answer.  21.2. In the year 1995, what is the difference between the Total Labor Force (in %) in Libya and Total Labor Force (in %) in Montenegro?
Keep it short and to the point. -28.1. In the year 1996, what is the difference between the Total Labor Force (in %) of Gambia, The and Total Labor Force (in %) of Libya?
Your response must be concise. 46.5. In the year 1996, what is the difference between the Total Labor Force (in %) of Ghana and Total Labor Force (in %) of Libya?
Your answer should be very brief. 48.4. In the year 1996, what is the difference between the Total Labor Force (in %) in Ghana and Total Labor Force (in %) in Montenegro?
Your answer should be compact. 21.8. In the year 1996, what is the difference between the Total Labor Force (in %) in Libya and Total Labor Force (in %) in Montenegro?
Your answer should be compact. -26.6. In the year 1997, what is the difference between the Total Labor Force (in %) of Gambia, The and Total Labor Force (in %) of Libya?
Make the answer very short. 45.6. In the year 1997, what is the difference between the Total Labor Force (in %) in Gambia, The and Total Labor Force (in %) in Montenegro?
Keep it short and to the point. 20.1. In the year 1997, what is the difference between the Total Labor Force (in %) in Ghana and Total Labor Force (in %) in Libya?
Ensure brevity in your answer.  47.7. In the year 1997, what is the difference between the Total Labor Force (in %) in Ghana and Total Labor Force (in %) in Montenegro?
Ensure brevity in your answer.  22.2. In the year 1997, what is the difference between the Total Labor Force (in %) in Libya and Total Labor Force (in %) in Montenegro?
Your response must be concise. -25.5. In the year 1998, what is the difference between the Total Labor Force (in %) in Gambia, The and Total Labor Force (in %) in Libya?
Ensure brevity in your answer.  44.6. In the year 1998, what is the difference between the Total Labor Force (in %) of Gambia, The and Total Labor Force (in %) of Montenegro?
Your answer should be compact. 20.4. In the year 1998, what is the difference between the Total Labor Force (in %) of Ghana and Total Labor Force (in %) of Libya?
Your answer should be compact. 46.7. In the year 1998, what is the difference between the Total Labor Force (in %) of Ghana and Total Labor Force (in %) of Montenegro?
Offer a terse response. 22.5. In the year 1998, what is the difference between the Total Labor Force (in %) of Libya and Total Labor Force (in %) of Montenegro?
Give a very brief answer. -24.2. In the year 1999, what is the difference between the Total Labor Force (in %) of Gambia, The and Total Labor Force (in %) of Ghana?
Ensure brevity in your answer.  -2.3. In the year 1999, what is the difference between the Total Labor Force (in %) in Gambia, The and Total Labor Force (in %) in Libya?
Provide a short and direct response. 43.6. In the year 1999, what is the difference between the Total Labor Force (in %) in Gambia, The and Total Labor Force (in %) in Montenegro?
Your answer should be very brief. 20.1. In the year 1999, what is the difference between the Total Labor Force (in %) of Ghana and Total Labor Force (in %) of Libya?
Your answer should be compact. 45.9. In the year 1999, what is the difference between the Total Labor Force (in %) of Ghana and Total Labor Force (in %) of Montenegro?
Offer a terse response. 22.4. In the year 1999, what is the difference between the Total Labor Force (in %) of Libya and Total Labor Force (in %) of Montenegro?
Provide a short and direct response. -23.5. In the year 2000, what is the difference between the Total Labor Force (in %) of Gambia, The and Total Labor Force (in %) of Libya?
Your answer should be compact. 42.8. In the year 2000, what is the difference between the Total Labor Force (in %) of Gambia, The and Total Labor Force (in %) of Montenegro?
Your answer should be compact. 20.2. In the year 2000, what is the difference between the Total Labor Force (in %) in Ghana and Total Labor Force (in %) in Libya?
Make the answer very short. 45.2. In the year 2000, what is the difference between the Total Labor Force (in %) in Ghana and Total Labor Force (in %) in Montenegro?
Your answer should be compact. 22.6. In the year 2000, what is the difference between the Total Labor Force (in %) in Libya and Total Labor Force (in %) in Montenegro?
Your answer should be compact. -22.6. What is the ratio of the Total Labor Force (in %) of Libya in 1993 to that in 1994?
Keep it short and to the point. 0.96. What is the ratio of the Total Labor Force (in %) in Montenegro in 1993 to that in 1994?
Offer a terse response. 1. What is the ratio of the Total Labor Force (in %) of Gambia, The in 1993 to that in 1995?
Offer a terse response. 0.99. What is the ratio of the Total Labor Force (in %) of Ghana in 1993 to that in 1995?
Offer a terse response. 0.99. What is the ratio of the Total Labor Force (in %) of Libya in 1993 to that in 1995?
Provide a succinct answer. 0.92. What is the ratio of the Total Labor Force (in %) in Montenegro in 1993 to that in 1995?
Make the answer very short. 1.01. What is the ratio of the Total Labor Force (in %) in Gambia, The in 1993 to that in 1996?
Make the answer very short. 0.99. What is the ratio of the Total Labor Force (in %) of Ghana in 1993 to that in 1996?
Make the answer very short. 0.99. What is the ratio of the Total Labor Force (in %) of Libya in 1993 to that in 1996?
Provide a short and direct response. 0.88. What is the ratio of the Total Labor Force (in %) in Montenegro in 1993 to that in 1996?
Keep it short and to the point. 1.01. What is the ratio of the Total Labor Force (in %) of Gambia, The in 1993 to that in 1997?
Make the answer very short. 0.99. What is the ratio of the Total Labor Force (in %) in Ghana in 1993 to that in 1997?
Keep it short and to the point. 0.98. What is the ratio of the Total Labor Force (in %) in Libya in 1993 to that in 1997?
Your response must be concise. 0.84. What is the ratio of the Total Labor Force (in %) of Montenegro in 1993 to that in 1997?
Your answer should be compact. 1.01. What is the ratio of the Total Labor Force (in %) in Gambia, The in 1993 to that in 1998?
Offer a terse response. 0.98. What is the ratio of the Total Labor Force (in %) in Ghana in 1993 to that in 1998?
Keep it short and to the point. 0.98. What is the ratio of the Total Labor Force (in %) in Libya in 1993 to that in 1998?
Provide a succinct answer. 0.8. What is the ratio of the Total Labor Force (in %) in Montenegro in 1993 to that in 1998?
Your response must be concise. 1.01. What is the ratio of the Total Labor Force (in %) in Gambia, The in 1993 to that in 1999?
Make the answer very short. 0.98. What is the ratio of the Total Labor Force (in %) in Ghana in 1993 to that in 1999?
Offer a terse response. 0.97. What is the ratio of the Total Labor Force (in %) in Libya in 1993 to that in 1999?
Keep it short and to the point. 0.77. What is the ratio of the Total Labor Force (in %) of Ghana in 1993 to that in 2000?
Give a very brief answer. 0.97. What is the ratio of the Total Labor Force (in %) in Libya in 1993 to that in 2000?
Give a very brief answer. 0.74. What is the ratio of the Total Labor Force (in %) in Libya in 1994 to that in 1995?
Make the answer very short. 0.96. What is the ratio of the Total Labor Force (in %) in Montenegro in 1994 to that in 1995?
Offer a terse response. 1. What is the ratio of the Total Labor Force (in %) in Libya in 1994 to that in 1996?
Provide a succinct answer. 0.91. What is the ratio of the Total Labor Force (in %) in Montenegro in 1994 to that in 1996?
Your response must be concise. 1.01. What is the ratio of the Total Labor Force (in %) in Ghana in 1994 to that in 1997?
Provide a succinct answer. 0.99. What is the ratio of the Total Labor Force (in %) in Libya in 1994 to that in 1997?
Provide a short and direct response. 0.87. What is the ratio of the Total Labor Force (in %) of Montenegro in 1994 to that in 1997?
Provide a succinct answer. 1.01. What is the ratio of the Total Labor Force (in %) in Ghana in 1994 to that in 1998?
Offer a terse response. 0.98. What is the ratio of the Total Labor Force (in %) of Libya in 1994 to that in 1998?
Provide a short and direct response. 0.83. What is the ratio of the Total Labor Force (in %) in Montenegro in 1994 to that in 1998?
Provide a short and direct response. 1.01. What is the ratio of the Total Labor Force (in %) in Gambia, The in 1994 to that in 1999?
Give a very brief answer. 0.98. What is the ratio of the Total Labor Force (in %) in Ghana in 1994 to that in 1999?
Offer a terse response. 0.98. What is the ratio of the Total Labor Force (in %) in Libya in 1994 to that in 1999?
Ensure brevity in your answer.  0.79. What is the ratio of the Total Labor Force (in %) in Montenegro in 1994 to that in 1999?
Ensure brevity in your answer.  1. What is the ratio of the Total Labor Force (in %) in Gambia, The in 1994 to that in 2000?
Make the answer very short. 0.98. What is the ratio of the Total Labor Force (in %) of Ghana in 1994 to that in 2000?
Your answer should be compact. 0.97. What is the ratio of the Total Labor Force (in %) of Libya in 1994 to that in 2000?
Your answer should be compact. 0.77. What is the ratio of the Total Labor Force (in %) in Libya in 1995 to that in 1996?
Your response must be concise. 0.95. What is the ratio of the Total Labor Force (in %) of Montenegro in 1995 to that in 1996?
Your answer should be very brief. 1.01. What is the ratio of the Total Labor Force (in %) in Ghana in 1995 to that in 1997?
Provide a short and direct response. 0.99. What is the ratio of the Total Labor Force (in %) in Montenegro in 1995 to that in 1997?
Make the answer very short. 1.01. What is the ratio of the Total Labor Force (in %) in Ghana in 1995 to that in 1998?
Provide a short and direct response. 0.99. What is the ratio of the Total Labor Force (in %) in Libya in 1995 to that in 1998?
Provide a short and direct response. 0.86. What is the ratio of the Total Labor Force (in %) in Montenegro in 1995 to that in 1998?
Provide a succinct answer. 1.01. What is the ratio of the Total Labor Force (in %) of Gambia, The in 1995 to that in 1999?
Offer a very short reply. 0.99. What is the ratio of the Total Labor Force (in %) of Ghana in 1995 to that in 1999?
Your answer should be compact. 0.98. What is the ratio of the Total Labor Force (in %) of Libya in 1995 to that in 1999?
Provide a short and direct response. 0.83. What is the ratio of the Total Labor Force (in %) in Gambia, The in 1995 to that in 2000?
Your answer should be very brief. 0.98. What is the ratio of the Total Labor Force (in %) in Ghana in 1995 to that in 2000?
Offer a terse response. 0.98. What is the ratio of the Total Labor Force (in %) in Libya in 1995 to that in 2000?
Your answer should be very brief. 0.8. What is the ratio of the Total Labor Force (in %) of Montenegro in 1995 to that in 2000?
Provide a short and direct response. 1. What is the ratio of the Total Labor Force (in %) in Gambia, The in 1996 to that in 1997?
Offer a very short reply. 1. What is the ratio of the Total Labor Force (in %) of Libya in 1996 to that in 1997?
Your answer should be compact. 0.96. What is the ratio of the Total Labor Force (in %) of Ghana in 1996 to that in 1998?
Your answer should be compact. 0.99. What is the ratio of the Total Labor Force (in %) in Libya in 1996 to that in 1998?
Provide a short and direct response. 0.91. What is the ratio of the Total Labor Force (in %) of Montenegro in 1996 to that in 1998?
Offer a terse response. 1. What is the ratio of the Total Labor Force (in %) of Gambia, The in 1996 to that in 1999?
Keep it short and to the point. 0.99. What is the ratio of the Total Labor Force (in %) in Ghana in 1996 to that in 1999?
Provide a succinct answer. 0.99. What is the ratio of the Total Labor Force (in %) in Libya in 1996 to that in 1999?
Give a very brief answer. 0.87. What is the ratio of the Total Labor Force (in %) in Montenegro in 1996 to that in 1999?
Offer a terse response. 0.99. What is the ratio of the Total Labor Force (in %) of Ghana in 1996 to that in 2000?
Offer a terse response. 0.98. What is the ratio of the Total Labor Force (in %) in Libya in 1996 to that in 2000?
Give a very brief answer. 0.84. What is the ratio of the Total Labor Force (in %) in Montenegro in 1996 to that in 2000?
Offer a terse response. 0.99. What is the ratio of the Total Labor Force (in %) in Gambia, The in 1997 to that in 1998?
Provide a short and direct response. 1. What is the ratio of the Total Labor Force (in %) in Ghana in 1997 to that in 1998?
Provide a succinct answer. 1. What is the ratio of the Total Labor Force (in %) in Libya in 1997 to that in 1998?
Your answer should be very brief. 0.95. What is the ratio of the Total Labor Force (in %) of Montenegro in 1997 to that in 1998?
Your response must be concise. 1. What is the ratio of the Total Labor Force (in %) of Gambia, The in 1997 to that in 1999?
Offer a terse response. 0.99. What is the ratio of the Total Labor Force (in %) in Libya in 1997 to that in 1999?
Offer a terse response. 0.91. What is the ratio of the Total Labor Force (in %) in Montenegro in 1997 to that in 1999?
Provide a short and direct response. 0.99. What is the ratio of the Total Labor Force (in %) in Ghana in 1997 to that in 2000?
Give a very brief answer. 0.99. What is the ratio of the Total Labor Force (in %) in Libya in 1997 to that in 2000?
Offer a terse response. 0.88. What is the ratio of the Total Labor Force (in %) in Montenegro in 1997 to that in 2000?
Your answer should be compact. 0.99. What is the ratio of the Total Labor Force (in %) in Ghana in 1998 to that in 1999?
Provide a short and direct response. 1. What is the ratio of the Total Labor Force (in %) of Libya in 1998 to that in 1999?
Provide a short and direct response. 0.96. What is the ratio of the Total Labor Force (in %) in Libya in 1998 to that in 2000?
Make the answer very short. 0.93. What is the ratio of the Total Labor Force (in %) of Montenegro in 1998 to that in 2000?
Give a very brief answer. 0.99. What is the ratio of the Total Labor Force (in %) in Libya in 1999 to that in 2000?
Your answer should be compact. 0.97. What is the difference between the highest and the lowest Total Labor Force (in %) in Gambia, The?
Your answer should be compact. 1.5. What is the difference between the highest and the lowest Total Labor Force (in %) of Montenegro?
Offer a terse response. 0.6. 